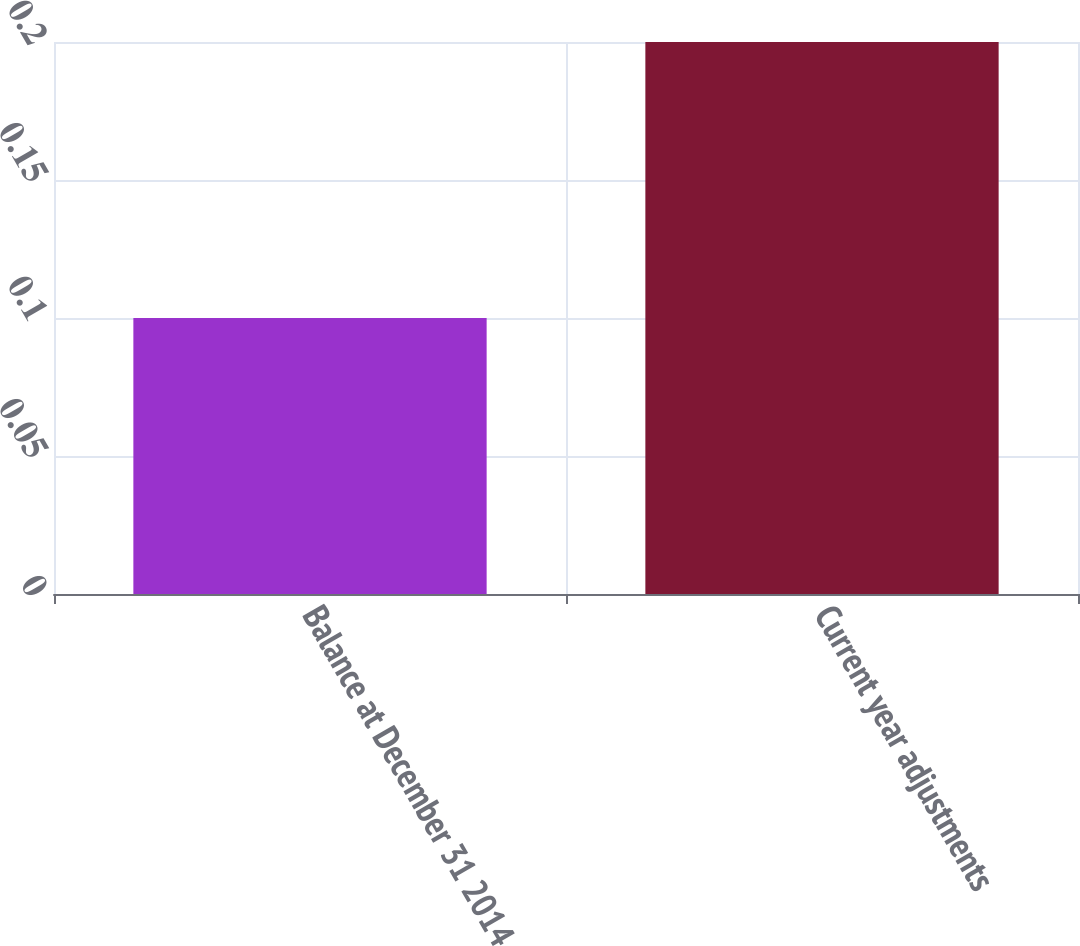Convert chart to OTSL. <chart><loc_0><loc_0><loc_500><loc_500><bar_chart><fcel>Balance at December 31 2014<fcel>Current year adjustments<nl><fcel>0.1<fcel>0.2<nl></chart> 